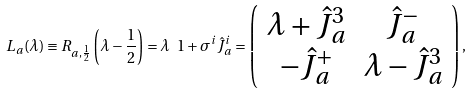<formula> <loc_0><loc_0><loc_500><loc_500>L _ { a } ( \lambda ) \equiv R _ { a , \frac { 1 } { 2 } } \left ( \lambda - \frac { 1 } { 2 } \right ) = \lambda \ 1 + \sigma ^ { i } \hat { J } ^ { i } _ { a } = \left ( \begin{array} { c c } \lambda + \hat { J } ^ { 3 } _ { a } & \hat { J } ^ { - } _ { a } \\ - \hat { J } ^ { + } _ { a } & \lambda - \hat { J } ^ { 3 } _ { a } \end{array} \right ) ,</formula> 